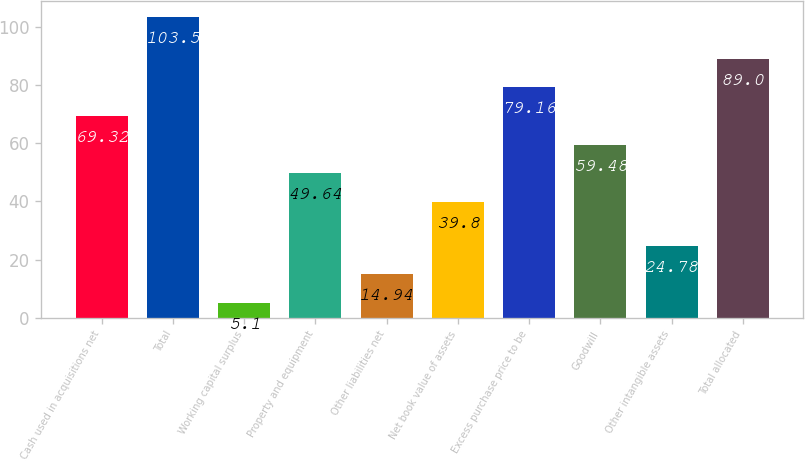Convert chart to OTSL. <chart><loc_0><loc_0><loc_500><loc_500><bar_chart><fcel>Cash used in acquisitions net<fcel>Total<fcel>Working capital surplus<fcel>Property and equipment<fcel>Other liabilities net<fcel>Net book value of assets<fcel>Excess purchase price to be<fcel>Goodwill<fcel>Other intangible assets<fcel>Total allocated<nl><fcel>69.32<fcel>103.5<fcel>5.1<fcel>49.64<fcel>14.94<fcel>39.8<fcel>79.16<fcel>59.48<fcel>24.78<fcel>89<nl></chart> 